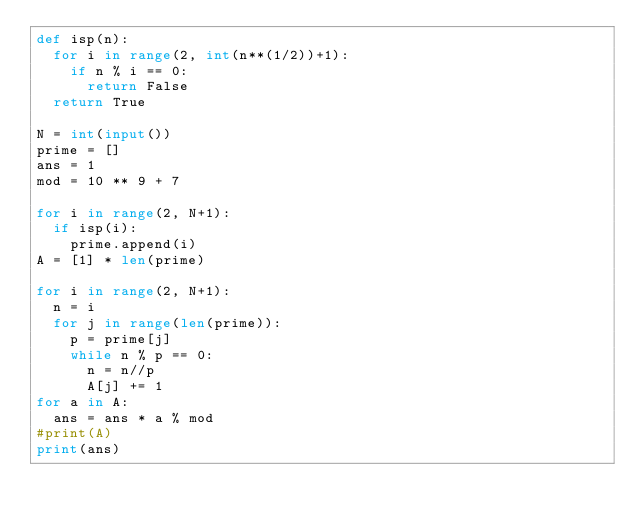Convert code to text. <code><loc_0><loc_0><loc_500><loc_500><_Python_>def isp(n):
  for i in range(2, int(n**(1/2))+1):
    if n % i == 0:
      return False
  return True    

N = int(input())
prime = []
ans = 1
mod = 10 ** 9 + 7

for i in range(2, N+1):
  if isp(i):
    prime.append(i)
A = [1] * len(prime)

for i in range(2, N+1):
  n = i
  for j in range(len(prime)):
    p = prime[j]
    while n % p == 0:
      n = n//p
      A[j] += 1
for a in A:
  ans = ans * a % mod
#print(A)
print(ans)</code> 